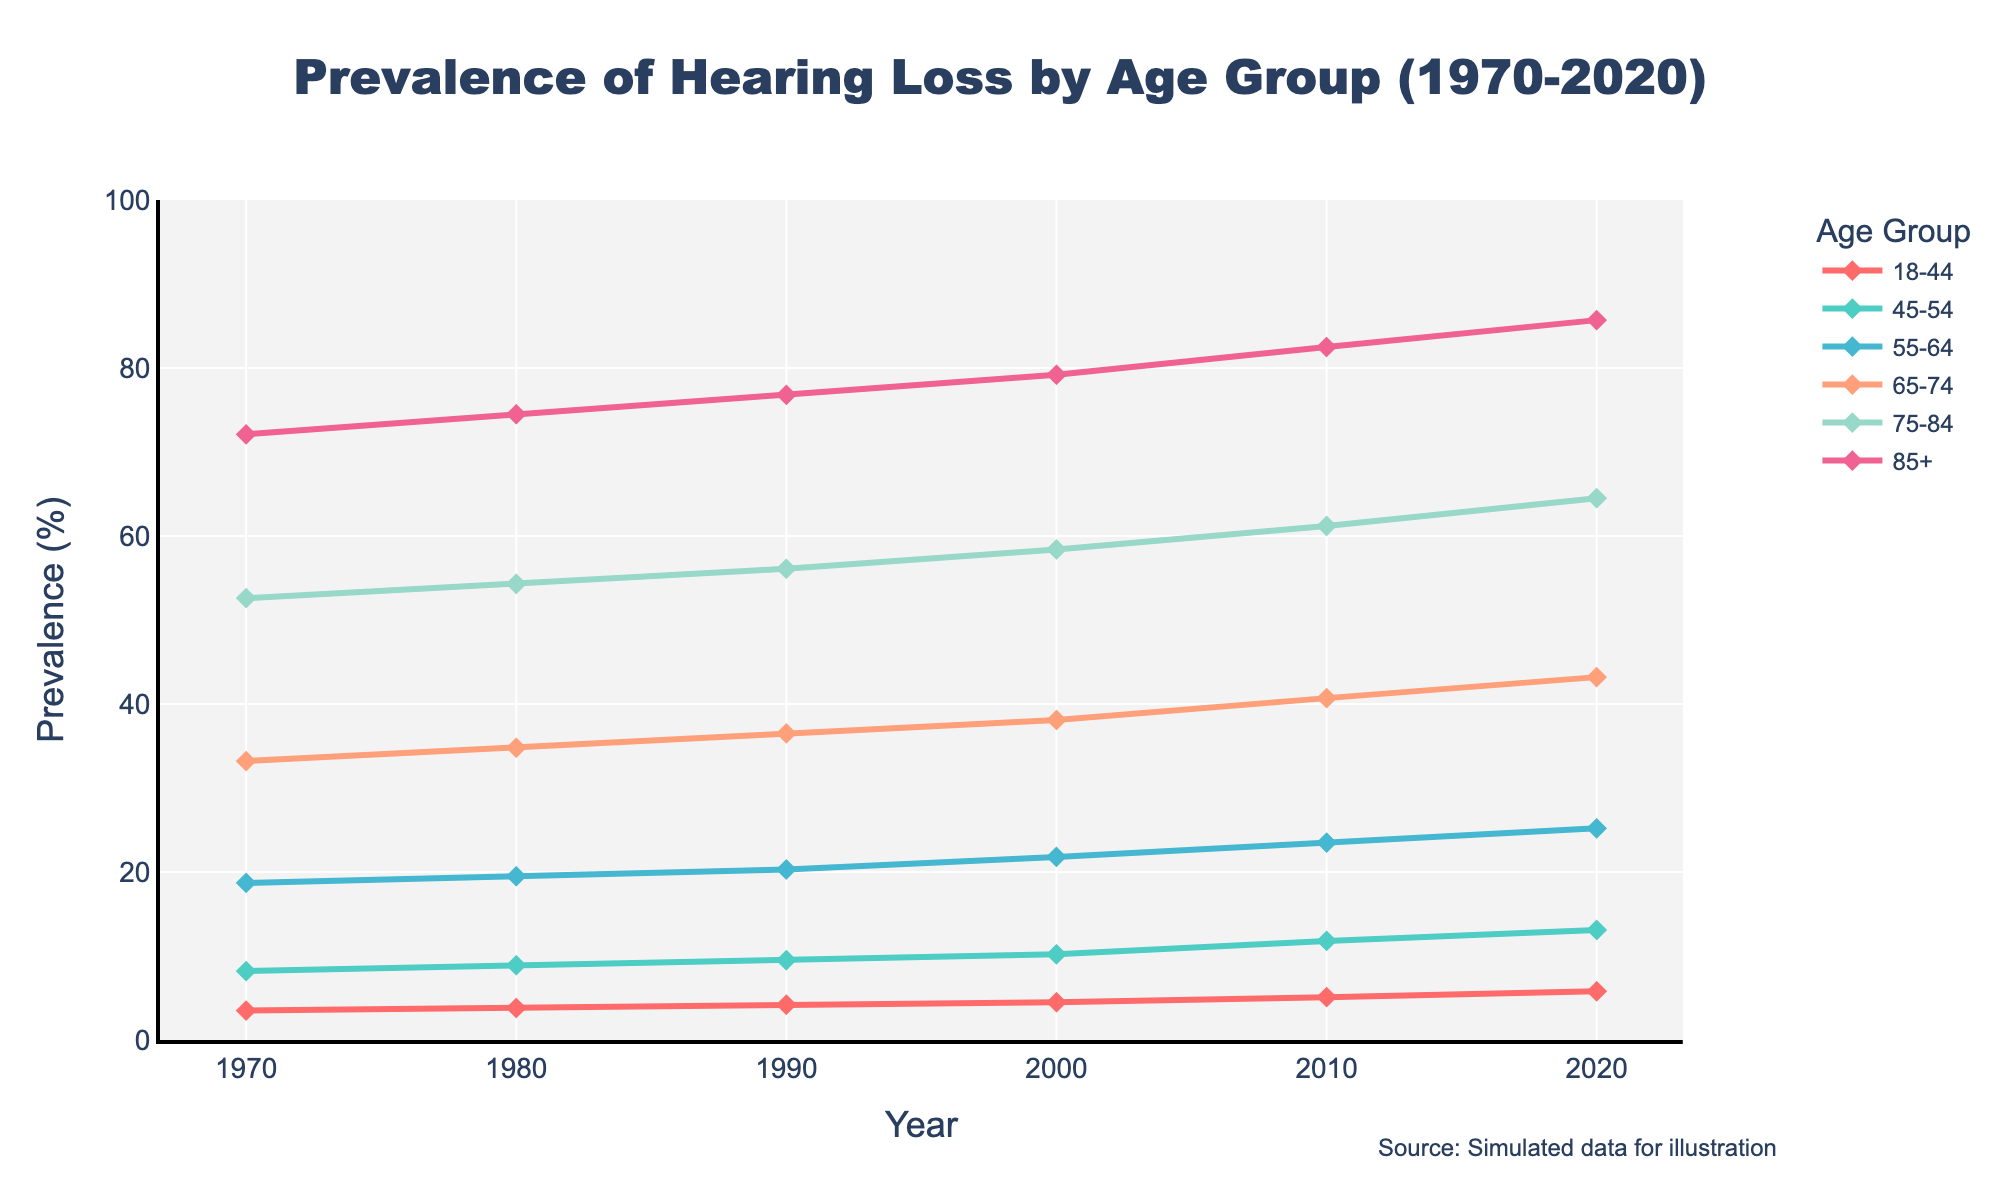What's the largest increase in prevalence (%) for any age group over the years? To determine the largest increase, subtract the prevalence in 1970 from the prevalence in 2020 for each age group. The calculations are: 85+ (85.7-72.1=13.6), 75-84 (64.5-52.6=11.9), 65-74 (43.2-33.2=10.0), 55-64 (25.2-18.7=6.5), 45-54 (13.1-8.2=4.9), 18-44 (5.8-3.5=2.3). The largest increase is for the 85+ age group with an increase of 13.6%.
Answer: 13.6% Which age group consistently showed the highest prevalence of hearing loss? By examining the lines on the graph, the 85+ age group consistently has the highest prevalence of hearing loss across all years shown.
Answer: 85+ In 2020, how much higher is the prevalence of hearing loss for the 75-84 age group compared to the 45-54 age group? In 2020, the prevalence for 75-84 is 64.5%, and for 45-54 it is 13.1%. The difference is 64.5 - 13.1 = 51.4.
Answer: 51.4% What is the average prevalence of hearing loss for the 55-64 age group over the 50 years? Add the numbers for the 55-64 age group across the years and divide by the number of data points: (18.7 + 19.5 + 20.3 + 21.8 + 23.5 + 25.2) / 6 = 21.5.
Answer: 21.5 In which decade did the 65-74 age group see the smallest increase in prevalence of hearing loss? Calculate the increase for each decade: 1970s (34.8-33.2=1.6), 1980s (36.5-34.8=1.7), 1990s (38.1-36.5=1.6), 2000s (40.7-38.1=2.6), 2010s (43.2-40.7=2.5). The smallest increase is in the 1970s and 1990s with an increase of 1.6%.
Answer: 1970s and 1990s Identify the age group with the smallest overall increase in prevalence of hearing loss from 1970 to 2020. Subtract the prevalence in 1970 from the prevalence in 2020 for each age group: calculate as before, and the smallest increase is for the 18-44 age group, with an increase of 2.3%.
Answer: 18-44 